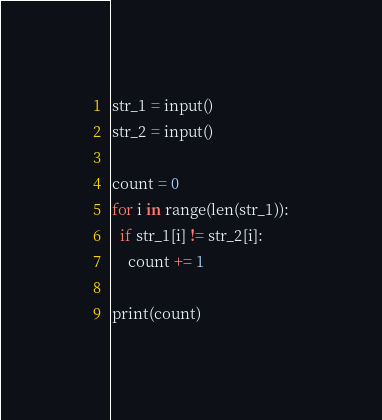<code> <loc_0><loc_0><loc_500><loc_500><_Python_>str_1 = input()
str_2 = input()

count = 0
for i in range(len(str_1)):
  if str_1[i] != str_2[i]:
    count += 1
    
print(count)</code> 